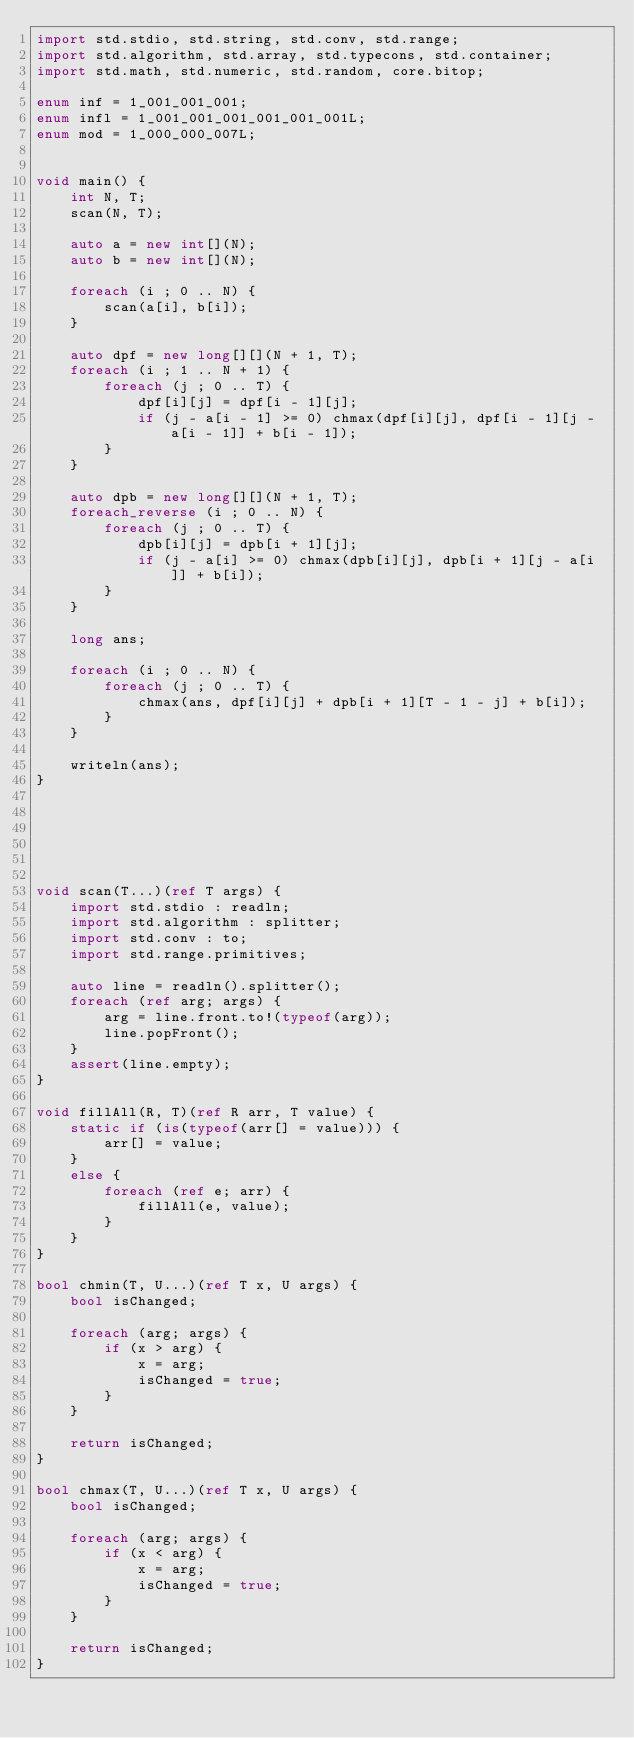<code> <loc_0><loc_0><loc_500><loc_500><_D_>import std.stdio, std.string, std.conv, std.range;
import std.algorithm, std.array, std.typecons, std.container;
import std.math, std.numeric, std.random, core.bitop;

enum inf = 1_001_001_001;
enum infl = 1_001_001_001_001_001_001L;
enum mod = 1_000_000_007L;


void main() {
    int N, T;
    scan(N, T);

    auto a = new int[](N);
    auto b = new int[](N);

    foreach (i ; 0 .. N) {
        scan(a[i], b[i]);
    }

    auto dpf = new long[][](N + 1, T);
    foreach (i ; 1 .. N + 1) {
        foreach (j ; 0 .. T) {
            dpf[i][j] = dpf[i - 1][j];
            if (j - a[i - 1] >= 0) chmax(dpf[i][j], dpf[i - 1][j - a[i - 1]] + b[i - 1]);
        }
    }

    auto dpb = new long[][](N + 1, T);
    foreach_reverse (i ; 0 .. N) {
        foreach (j ; 0 .. T) {
            dpb[i][j] = dpb[i + 1][j];
            if (j - a[i] >= 0) chmax(dpb[i][j], dpb[i + 1][j - a[i]] + b[i]);
        }
    }

    long ans;

    foreach (i ; 0 .. N) {
        foreach (j ; 0 .. T) {
            chmax(ans, dpf[i][j] + dpb[i + 1][T - 1 - j] + b[i]);
        }
    }

    writeln(ans);
}






void scan(T...)(ref T args) {
    import std.stdio : readln;
    import std.algorithm : splitter;
    import std.conv : to;
    import std.range.primitives;

    auto line = readln().splitter();
    foreach (ref arg; args) {
        arg = line.front.to!(typeof(arg));
        line.popFront();
    }
    assert(line.empty);
}

void fillAll(R, T)(ref R arr, T value) {
    static if (is(typeof(arr[] = value))) {
        arr[] = value;
    }
    else {
        foreach (ref e; arr) {
            fillAll(e, value);
        }
    }
}

bool chmin(T, U...)(ref T x, U args) {
    bool isChanged;

    foreach (arg; args) {
        if (x > arg) {
            x = arg;
            isChanged = true;
        }
    }

    return isChanged;
}

bool chmax(T, U...)(ref T x, U args) {
    bool isChanged;

    foreach (arg; args) {
        if (x < arg) {
            x = arg;
            isChanged = true;
        }
    }

    return isChanged;
}
</code> 